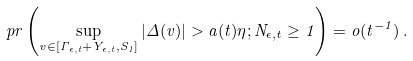<formula> <loc_0><loc_0><loc_500><loc_500>\ p r \left ( \sup _ { v \in [ \Gamma _ { \epsilon , t } + Y _ { \epsilon , t } , S _ { 1 } ] } | \Delta ( v ) | > a ( t ) \eta ; N _ { \epsilon , t } \geq 1 \right ) = o ( t ^ { - 1 } ) \, .</formula> 